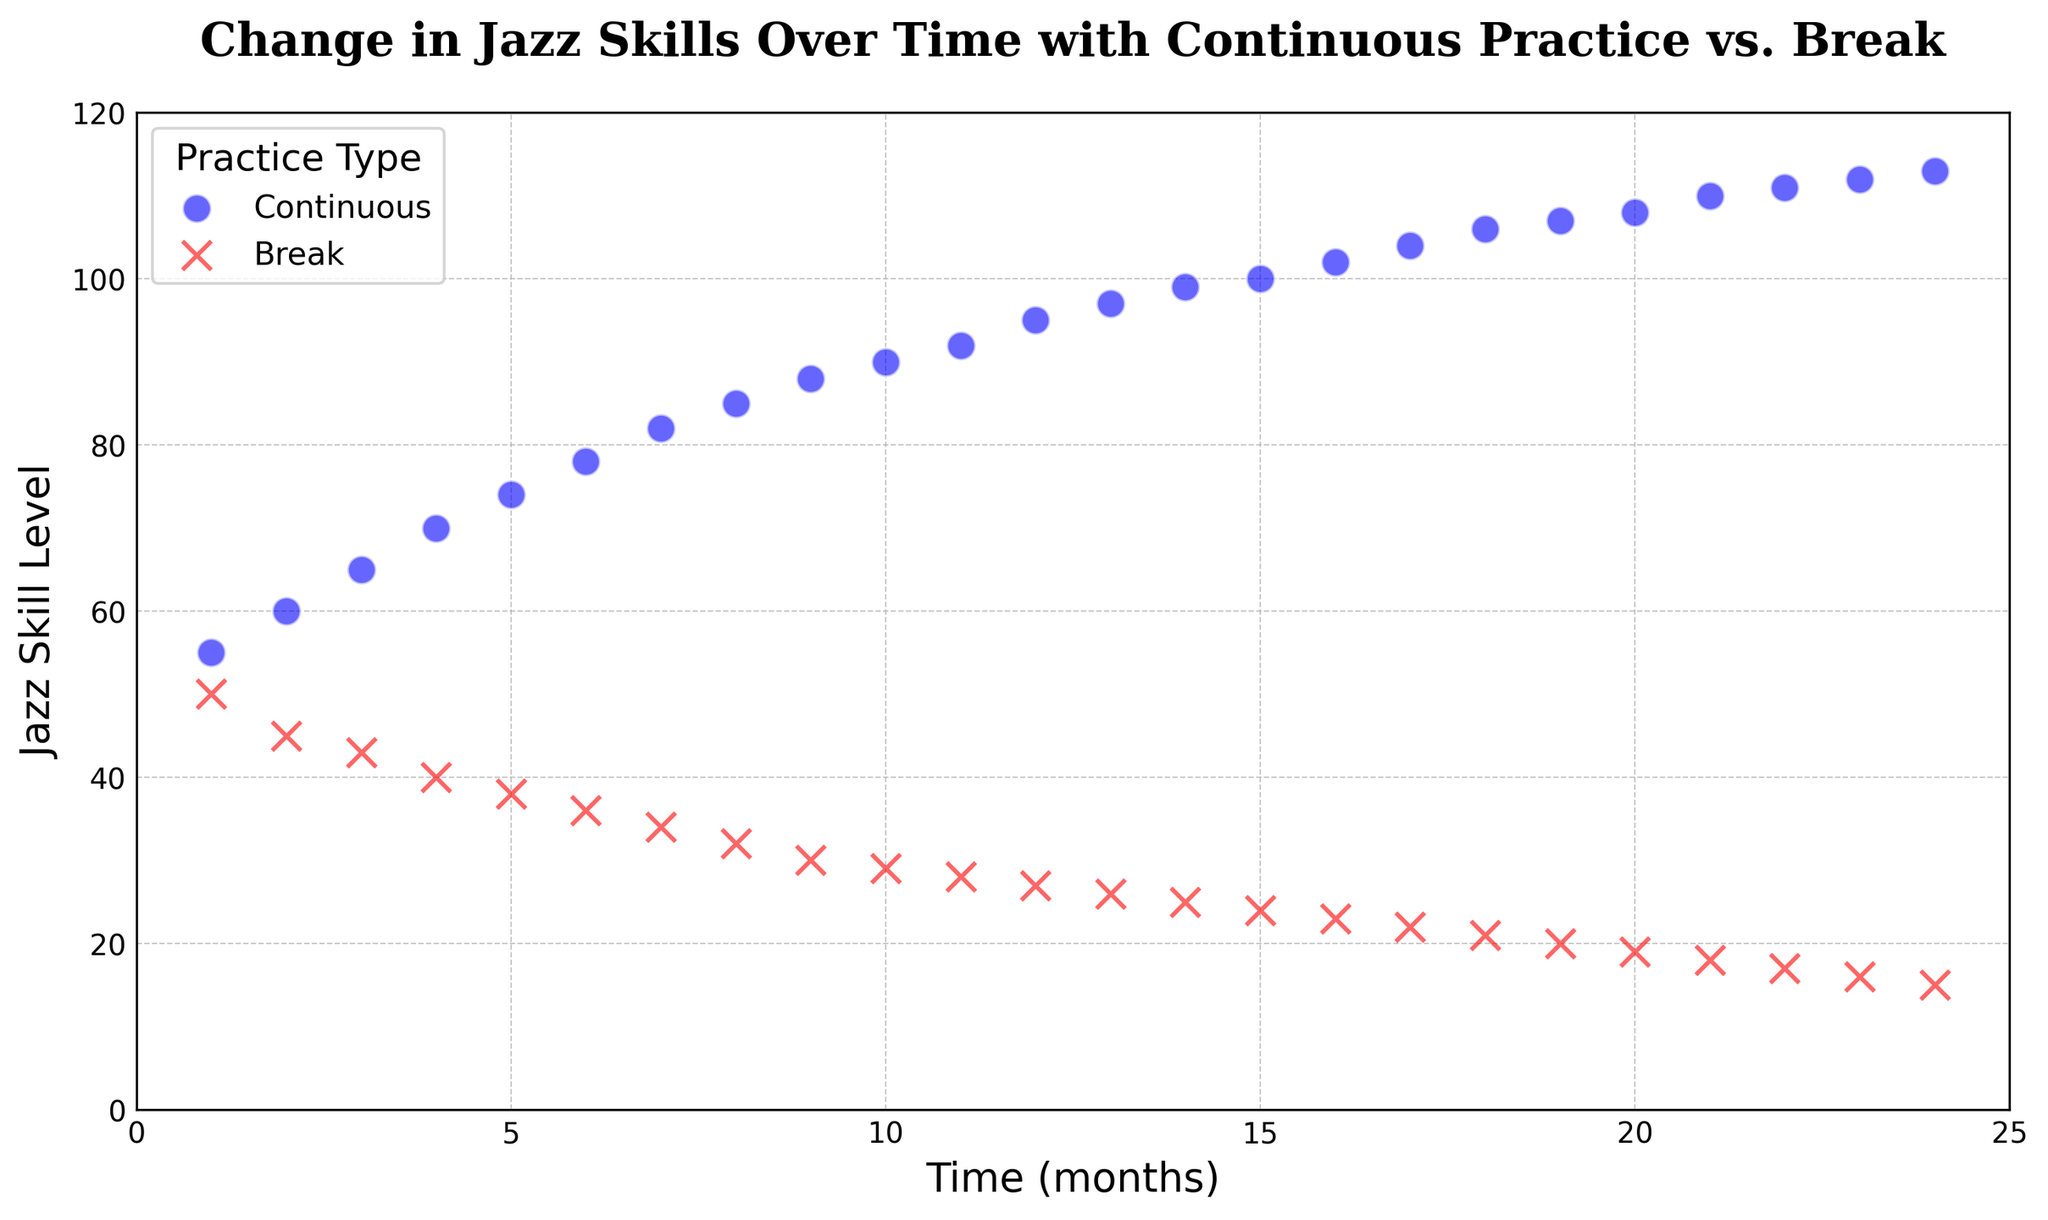What's the difference in Jazz Skill Level between Continuous and Break practices at 24 months? At 24 months, the Jazz Skill Level for Continuous practice is 113, and for Break practice, it is 15. The difference is 113 - 15.
Answer: 98 Which practice type shows a greater increase in Jazz Skill Level over time? Looking at the plot, the Continuous practice shows a steady increase in Jazz Skill Level over time, whereas the Break practice shows a decline.
Answer: Continuous Between months 12 and 15, how much does the Jazz Skill Level increase for Continuous practice? At 12 months, the Jazz Skill Level for Continuous practice is 95, and at 15 months, it is 100. The increase is 100 - 95.
Answer: 5 What is the Jazz Skill Level at 10 months for both Continuous and Break practices? At 10 months, the Jazz Skill Level for Continuous practice is 90, and for Break practice, it is 29.
Answer: Continuous: 90, Break: 29 How many months does it take for the Jazz Skill Level to reach 100 in Continuous practice? The Jazz Skill Level reaches 100 at 15 months in the Continuous practice condition.
Answer: 15 At which month is the largest difference in Jazz Skill Level between Continuous and Break practices observed? Observing the scatter plot, the largest difference occurs at the last measured time, which is 24 months.
Answer: 24 Is there any month where Continuous and Break practices have the same Jazz Skill Level? Observing the scatter plot, there is no month where both practice types have the same Jazz Skill Level.
Answer: No Between months 6 and 12, how much does the Jazz Skill Level decrease for Break practice? At 6 months, the Jazz Skill Level for Break practice is 36, and at 12 months, it is 27. The decrease is 36 - 27.
Answer: 9 What is the trend in Jazz Skill Levels for Continuous practice over the 24 months? The Jazz Skill Level for Continuous practice shows a steady upward trend from 55 to 113 over the 24 months.
Answer: Upward trend Which data point has the lowest Jazz Skill Level, and what is its practice type and month? The lowest Jazz Skill Level is 15, observed in Break practice at 24 months.
Answer: 24 months, Break, 15 